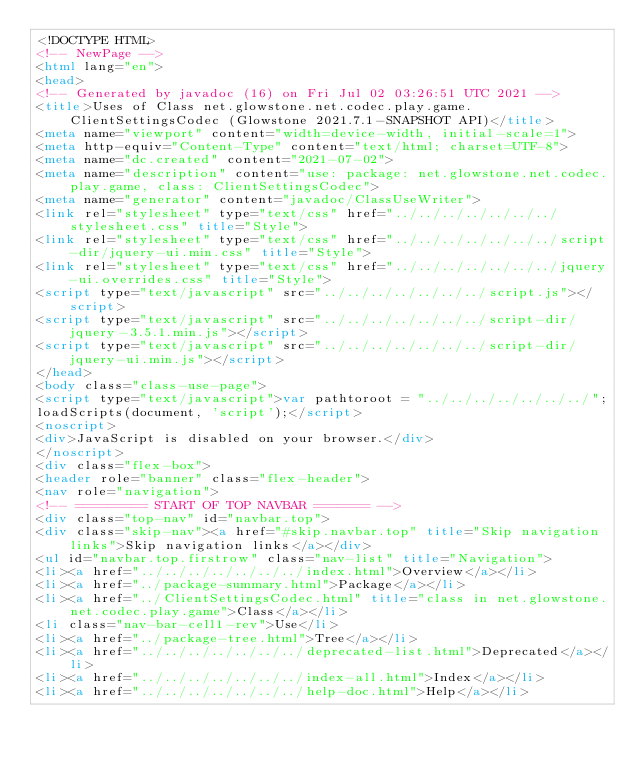Convert code to text. <code><loc_0><loc_0><loc_500><loc_500><_HTML_><!DOCTYPE HTML>
<!-- NewPage -->
<html lang="en">
<head>
<!-- Generated by javadoc (16) on Fri Jul 02 03:26:51 UTC 2021 -->
<title>Uses of Class net.glowstone.net.codec.play.game.ClientSettingsCodec (Glowstone 2021.7.1-SNAPSHOT API)</title>
<meta name="viewport" content="width=device-width, initial-scale=1">
<meta http-equiv="Content-Type" content="text/html; charset=UTF-8">
<meta name="dc.created" content="2021-07-02">
<meta name="description" content="use: package: net.glowstone.net.codec.play.game, class: ClientSettingsCodec">
<meta name="generator" content="javadoc/ClassUseWriter">
<link rel="stylesheet" type="text/css" href="../../../../../../../stylesheet.css" title="Style">
<link rel="stylesheet" type="text/css" href="../../../../../../../script-dir/jquery-ui.min.css" title="Style">
<link rel="stylesheet" type="text/css" href="../../../../../../../jquery-ui.overrides.css" title="Style">
<script type="text/javascript" src="../../../../../../../script.js"></script>
<script type="text/javascript" src="../../../../../../../script-dir/jquery-3.5.1.min.js"></script>
<script type="text/javascript" src="../../../../../../../script-dir/jquery-ui.min.js"></script>
</head>
<body class="class-use-page">
<script type="text/javascript">var pathtoroot = "../../../../../../../";
loadScripts(document, 'script');</script>
<noscript>
<div>JavaScript is disabled on your browser.</div>
</noscript>
<div class="flex-box">
<header role="banner" class="flex-header">
<nav role="navigation">
<!-- ========= START OF TOP NAVBAR ======= -->
<div class="top-nav" id="navbar.top">
<div class="skip-nav"><a href="#skip.navbar.top" title="Skip navigation links">Skip navigation links</a></div>
<ul id="navbar.top.firstrow" class="nav-list" title="Navigation">
<li><a href="../../../../../../../index.html">Overview</a></li>
<li><a href="../package-summary.html">Package</a></li>
<li><a href="../ClientSettingsCodec.html" title="class in net.glowstone.net.codec.play.game">Class</a></li>
<li class="nav-bar-cell1-rev">Use</li>
<li><a href="../package-tree.html">Tree</a></li>
<li><a href="../../../../../../../deprecated-list.html">Deprecated</a></li>
<li><a href="../../../../../../../index-all.html">Index</a></li>
<li><a href="../../../../../../../help-doc.html">Help</a></li></code> 